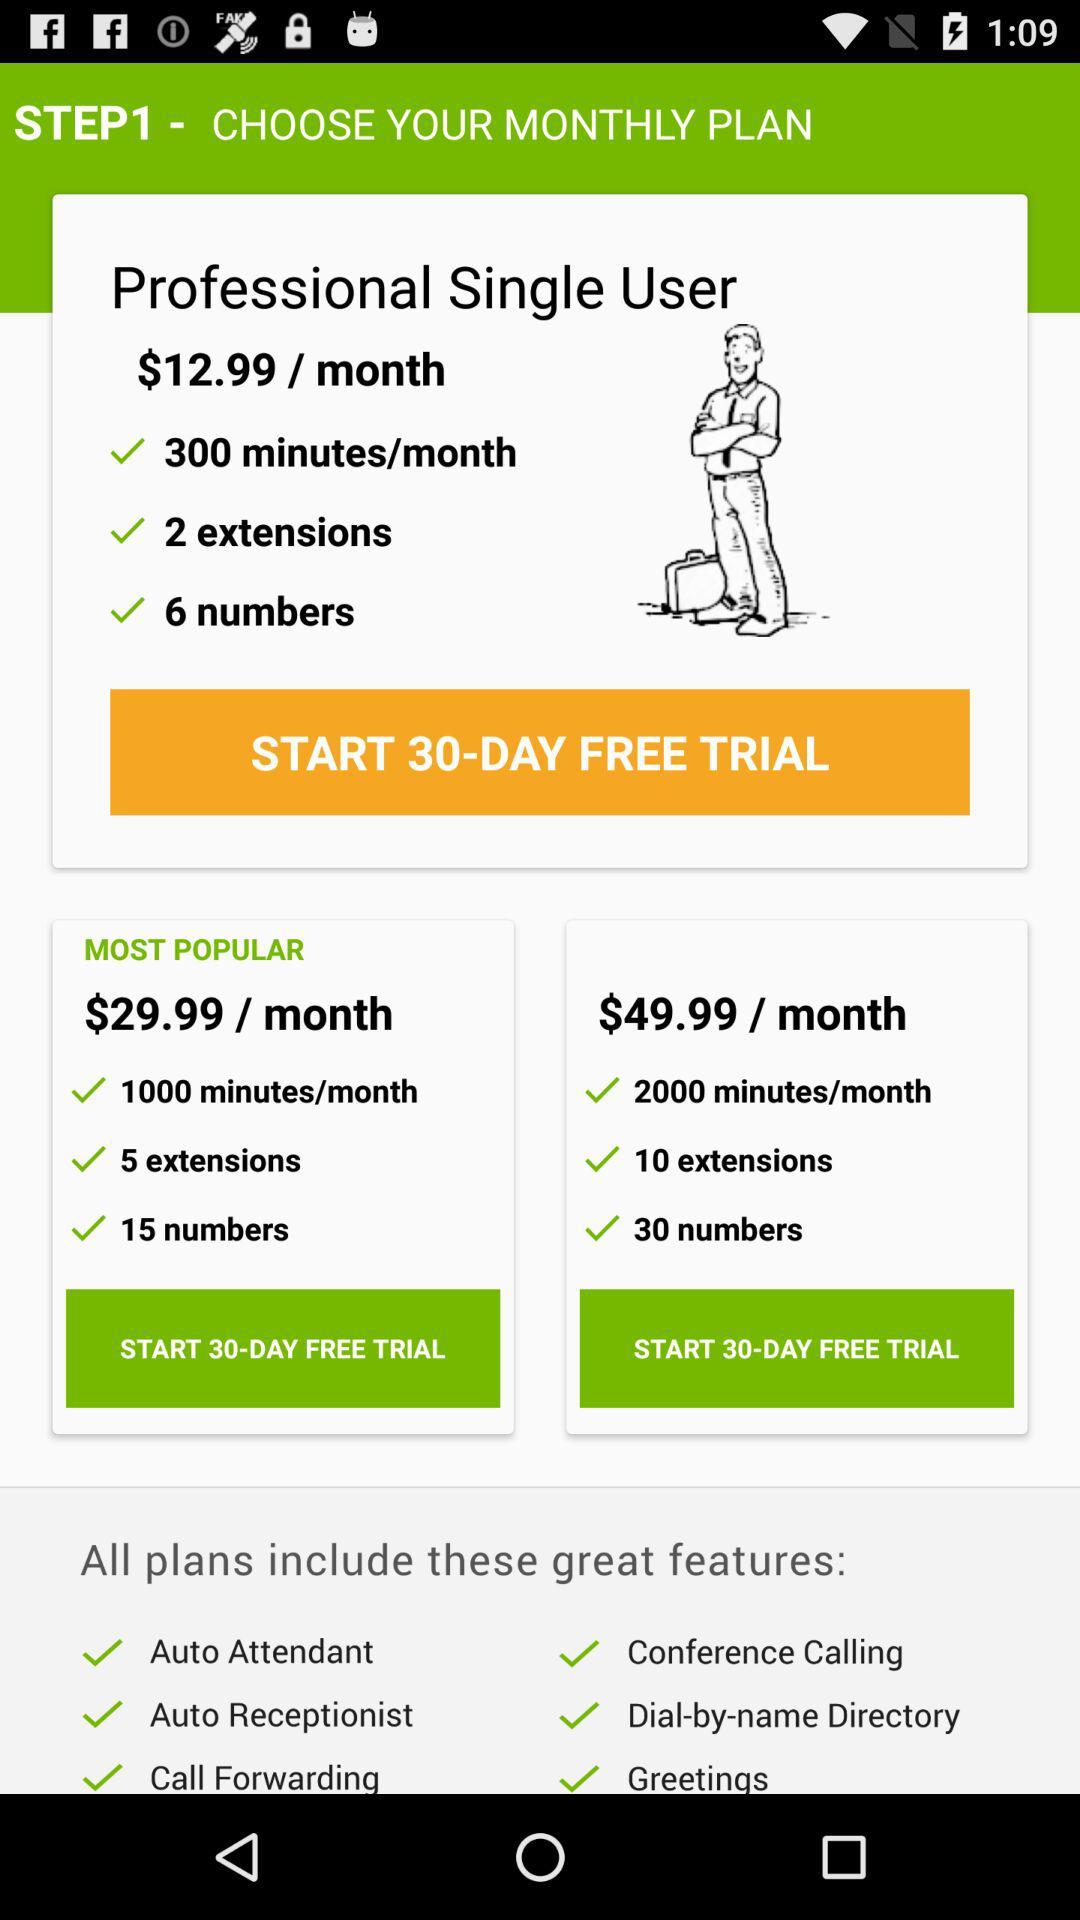How many extensions are there in the "Professional Single User" plan? There are 2 extensions. 